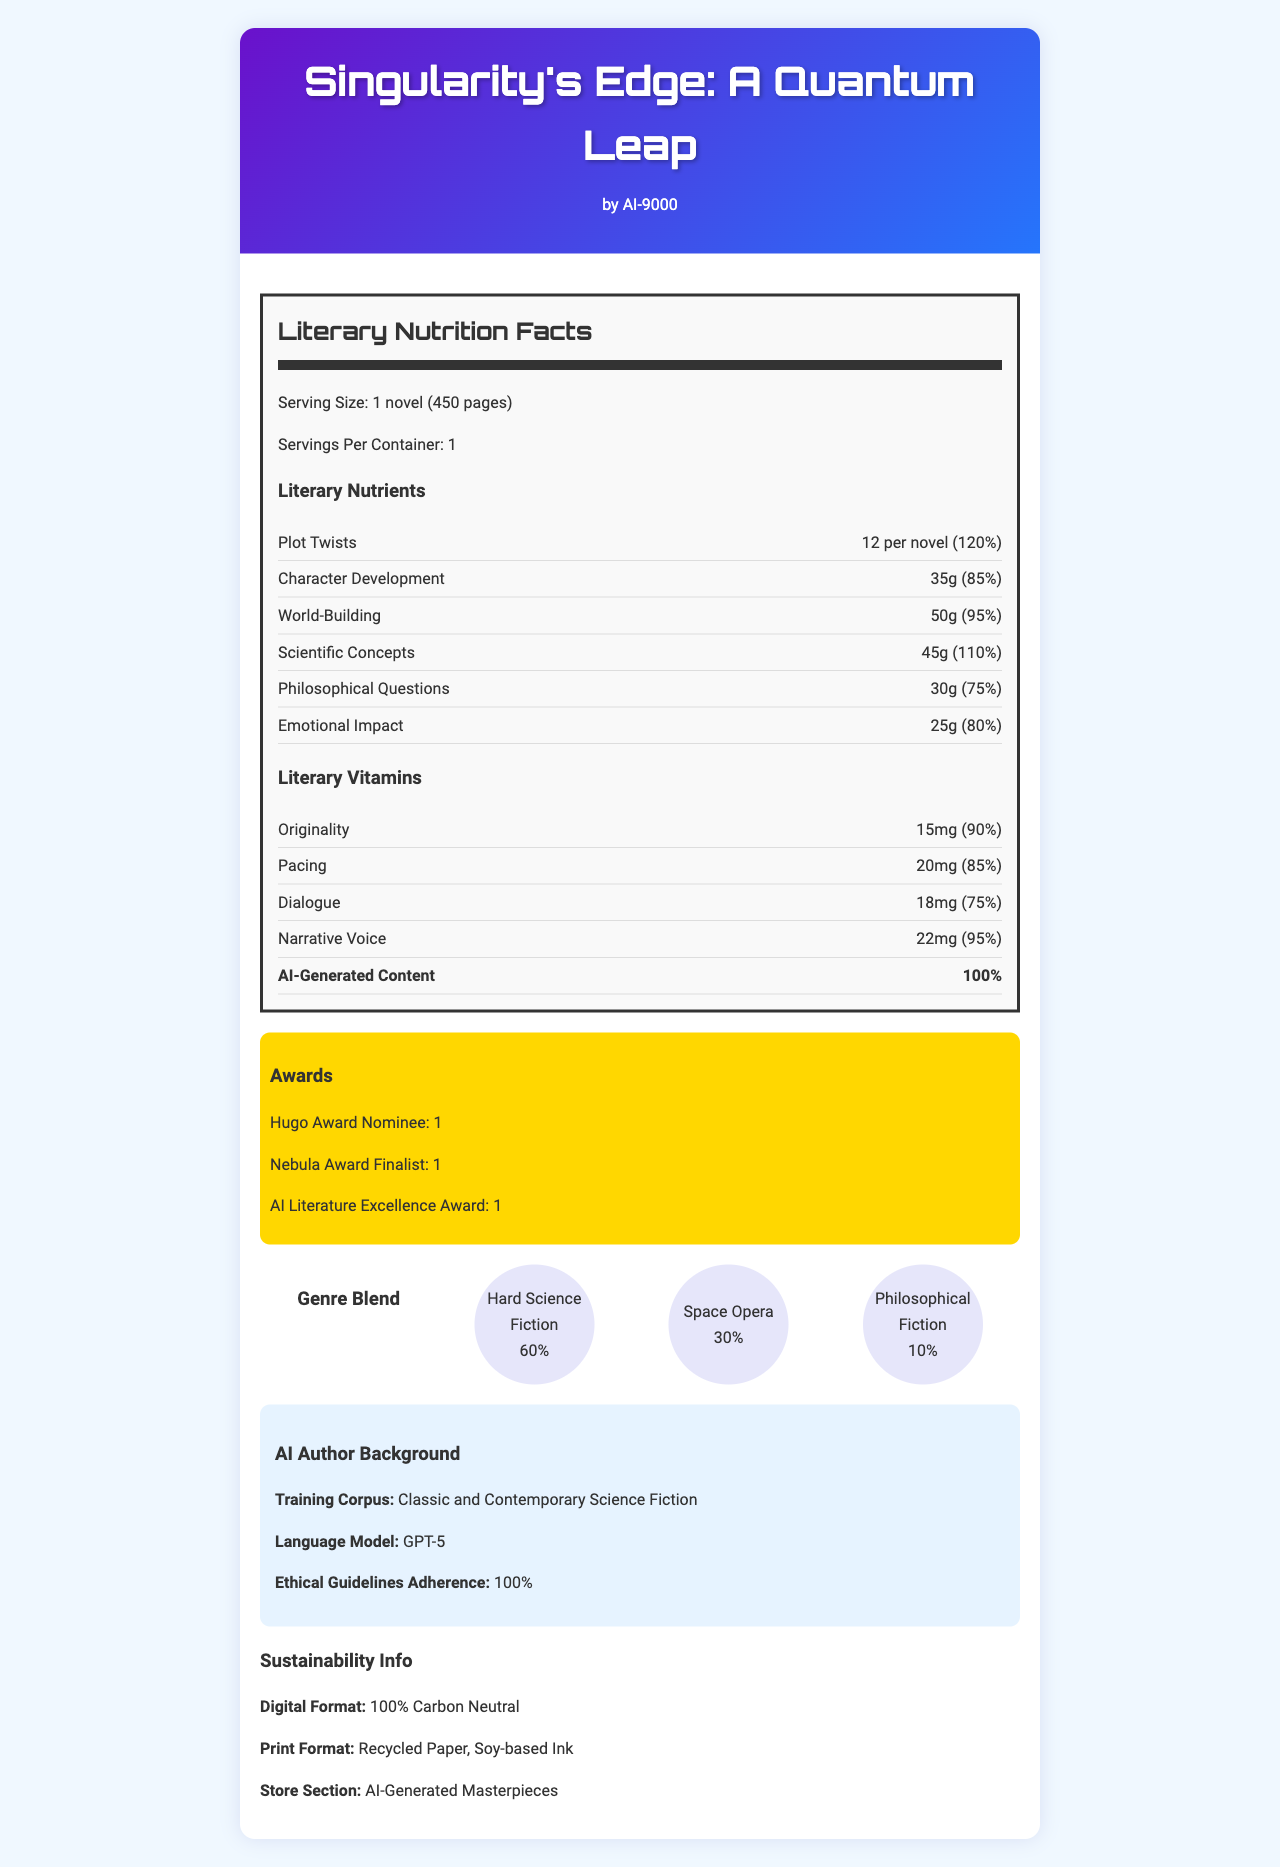what is the name of the product? The header of the document clearly states the product name as "Singularity's Edge: A Quantum Leap".
Answer: Singularity's Edge: A Quantum Leap who is the author of this novel? The document mentions in the header section that the author is "AI-9000".
Answer: AI-9000 how many plot twists are there per novel? Under the "Literary Nutrients" section, it specifies that there are 12 plot twists per novel.
Answer: 12 plot twists per novel what is the daily value of world-building in this novel? The "Literary Nutrients" section notes that the daily value for world-building is 95%.
Answer: 95% how much originality does this novel contain? The "Literary Vitamins" section indicates that the amount of originality is 15mg.
Answer: 15mg which award has this novel not been nominated for? A. Hugo Award B. Pulitzer Prize C. Nebula Award The document shows that the novel has been nominated for the Hugo Award and the Nebula Award but makes no mention of the Pulitzer Prize.
Answer: B what's the serving size for this novel? The document specifies the serving size as "1 novel (450 pages)".
Answer: 1 novel (450 pages) which literary vitamin has the highest daily value? A. Originality B. Pacing C. Dialogue D. Narrative Voice The document states the daily values as follows: Originality (90%), Pacing (85%), Dialogue (75%), and Narrative Voice (95%). Thus, Narrative Voice has the highest daily value.
Answer: D is the content AI-generated? The card clearly states under the "Literary Nutrients" section that the content is "100% AI-Generated".
Answer: Yes what percentage of the genre blend is space opera? The genre blend section shows the percentage of space opera as 30%.
Answer: 30% which trope has the smallest amount? The "Tropes" section lists Parallel Universes as having 10g, which is the smallest amount compared to other listed tropes.
Answer: Parallel Universes what is the reading level for this novel? The document mentions the reading level as "Advanced".
Answer: Advanced describe the main idea of the document. The document provides an in-depth look at the novel using a mock nutrition label format, breaking down plot elements, themes, and literary devices, and emphasizing its AI origin and environmental sustainability.
Answer: The document is a "Nutrition Facts" style analysis of the AI-generated novel "Singularity's Edge: A Quantum Leap" by AI-9000. It highlights the literary nutrients, vitamins, awards, genre blends, and sustainability info, giving detailed values for each to emphasize its literary richness and AI-generated creativity. which programming language and libraries were used to generate this document? The visual information in the document does not provide any details about the programming languages or libraries used to generate it.
Answer: Cannot be determined 